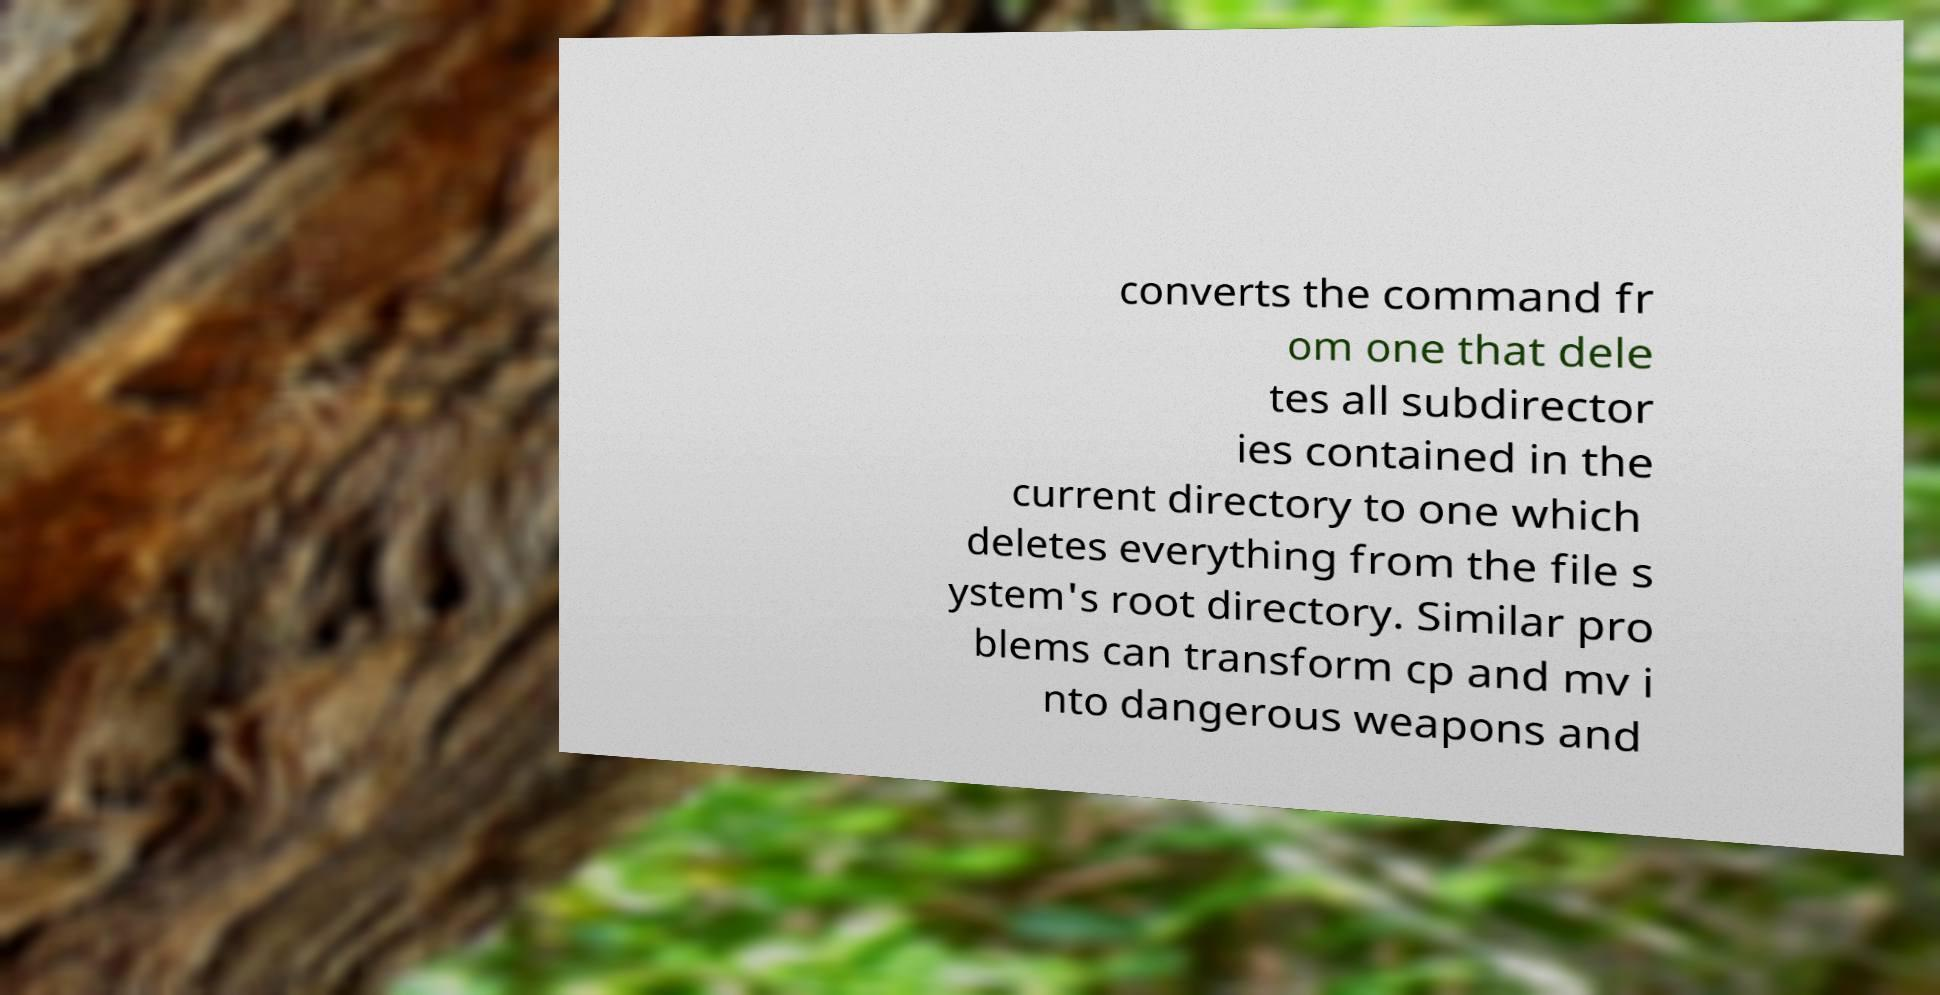Please read and relay the text visible in this image. What does it say? converts the command fr om one that dele tes all subdirector ies contained in the current directory to one which deletes everything from the file s ystem's root directory. Similar pro blems can transform cp and mv i nto dangerous weapons and 